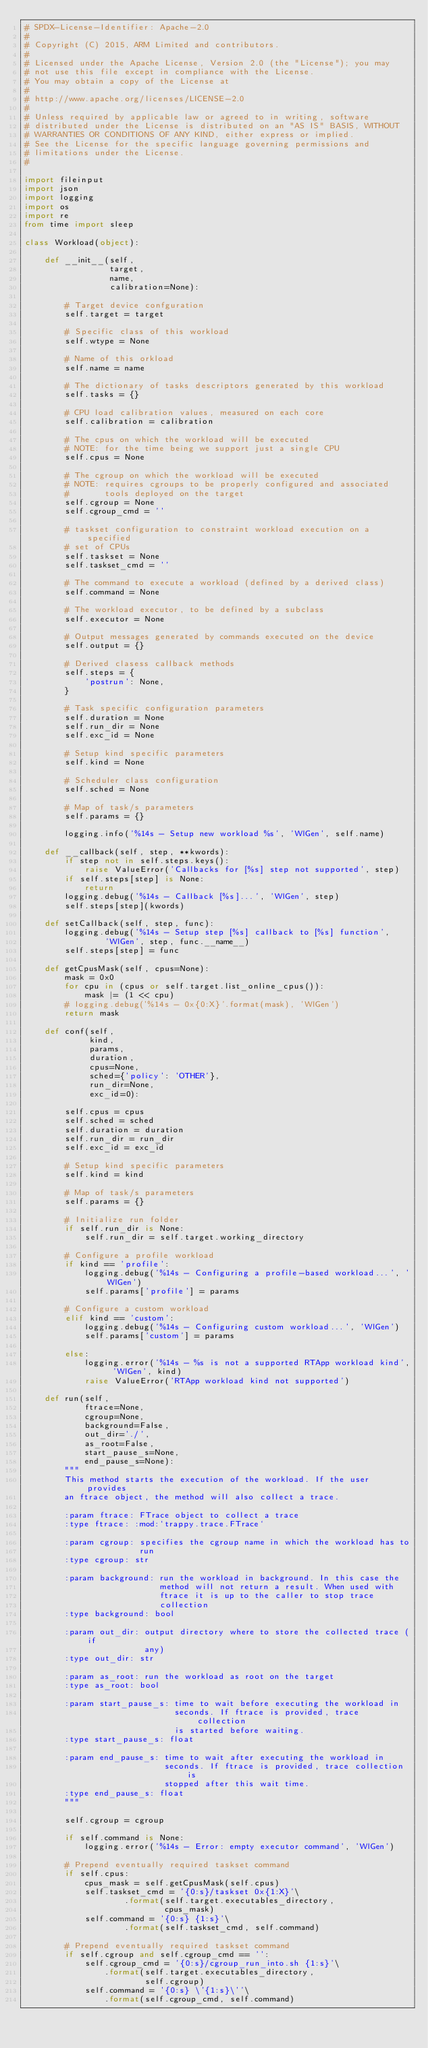<code> <loc_0><loc_0><loc_500><loc_500><_Python_># SPDX-License-Identifier: Apache-2.0
#
# Copyright (C) 2015, ARM Limited and contributors.
#
# Licensed under the Apache License, Version 2.0 (the "License"); you may
# not use this file except in compliance with the License.
# You may obtain a copy of the License at
#
# http://www.apache.org/licenses/LICENSE-2.0
#
# Unless required by applicable law or agreed to in writing, software
# distributed under the License is distributed on an "AS IS" BASIS, WITHOUT
# WARRANTIES OR CONDITIONS OF ANY KIND, either express or implied.
# See the License for the specific language governing permissions and
# limitations under the License.
#

import fileinput
import json
import logging
import os
import re
from time import sleep

class Workload(object):

    def __init__(self,
                 target,
                 name,
                 calibration=None):

        # Target device confguration
        self.target = target

        # Specific class of this workload
        self.wtype = None

        # Name of this orkload
        self.name = name

        # The dictionary of tasks descriptors generated by this workload
        self.tasks = {}

        # CPU load calibration values, measured on each core
        self.calibration = calibration

        # The cpus on which the workload will be executed
        # NOTE: for the time being we support just a single CPU
        self.cpus = None

	    # The cgroup on which the workload will be executed
        # NOTE: requires cgroups to be properly configured and associated
        #       tools deployed on the target
        self.cgroup = None
        self.cgroup_cmd = ''

        # taskset configuration to constraint workload execution on a specified
        # set of CPUs
        self.taskset = None
        self.taskset_cmd = ''

        # The command to execute a workload (defined by a derived class)
        self.command = None

        # The workload executor, to be defined by a subclass
        self.executor = None

        # Output messages generated by commands executed on the device
        self.output = {}

        # Derived clasess callback methods
        self.steps = {
            'postrun': None,
        }

        # Task specific configuration parameters
        self.duration = None
        self.run_dir = None
        self.exc_id = None

        # Setup kind specific parameters
        self.kind = None

        # Scheduler class configuration
        self.sched = None

        # Map of task/s parameters
        self.params = {}

        logging.info('%14s - Setup new workload %s', 'WlGen', self.name)

    def __callback(self, step, **kwords):
        if step not in self.steps.keys():
            raise ValueError('Callbacks for [%s] step not supported', step)
        if self.steps[step] is None:
            return
        logging.debug('%14s - Callback [%s]...', 'WlGen', step)
        self.steps[step](kwords)

    def setCallback(self, step, func):
        logging.debug('%14s - Setup step [%s] callback to [%s] function',
                'WlGen', step, func.__name__)
        self.steps[step] = func

    def getCpusMask(self, cpus=None):
        mask = 0x0
        for cpu in (cpus or self.target.list_online_cpus()):
            mask |= (1 << cpu)
        # logging.debug('%14s - 0x{0:X}'.format(mask), 'WlGen')
        return mask

    def conf(self,
             kind,
             params,
             duration,
             cpus=None,
             sched={'policy': 'OTHER'},
             run_dir=None,
             exc_id=0):

        self.cpus = cpus
        self.sched = sched
        self.duration = duration
        self.run_dir = run_dir
        self.exc_id = exc_id

        # Setup kind specific parameters
        self.kind = kind

        # Map of task/s parameters
        self.params = {}

        # Initialize run folder
        if self.run_dir is None:
            self.run_dir = self.target.working_directory

        # Configure a profile workload
        if kind == 'profile':
            logging.debug('%14s - Configuring a profile-based workload...', 'WlGen')
            self.params['profile'] = params

        # Configure a custom workload
        elif kind == 'custom':
            logging.debug('%14s - Configuring custom workload...', 'WlGen')
            self.params['custom'] = params

        else:
            logging.error('%14s - %s is not a supported RTApp workload kind', 'WlGen', kind)
            raise ValueError('RTApp workload kind not supported')

    def run(self,
            ftrace=None,
            cgroup=None,
            background=False,
            out_dir='./',
            as_root=False,
            start_pause_s=None,
            end_pause_s=None):
        """
        This method starts the execution of the workload. If the user provides
        an ftrace object, the method will also collect a trace.

        :param ftrace: FTrace object to collect a trace
        :type ftrace: :mod:`trappy.trace.FTrace`

        :param cgroup: specifies the cgroup name in which the workload has to
                       run
        :type cgroup: str

        :param background: run the workload in background. In this case the
                           method will not return a result. When used with
                           ftrace it is up to the caller to stop trace
                           collection
        :type background: bool

        :param out_dir: output directory where to store the collected trace (if
                        any)
        :type out_dir: str

        :param as_root: run the workload as root on the target
        :type as_root: bool

        :param start_pause_s: time to wait before executing the workload in
                              seconds. If ftrace is provided, trace collection
                              is started before waiting.
        :type start_pause_s: float

        :param end_pause_s: time to wait after executing the workload in
                            seconds. If ftrace is provided, trace collection is
                            stopped after this wait time.
        :type end_pause_s: float
        """

        self.cgroup = cgroup

        if self.command is None:
            logging.error('%14s - Error: empty executor command', 'WlGen')

        # Prepend eventually required taskset command
        if self.cpus:
            cpus_mask = self.getCpusMask(self.cpus)
            self.taskset_cmd = '{0:s}/taskset 0x{1:X}'\
                    .format(self.target.executables_directory,
                            cpus_mask)
            self.command = '{0:s} {1:s}'\
                    .format(self.taskset_cmd, self.command)

        # Prepend eventually required taskset command
        if self.cgroup and self.cgroup_cmd == '':
            self.cgroup_cmd = '{0:s}/cgroup_run_into.sh {1:s}'\
                .format(self.target.executables_directory,
                        self.cgroup)
            self.command = '{0:s} \'{1:s}\''\
                .format(self.cgroup_cmd, self.command)
</code> 